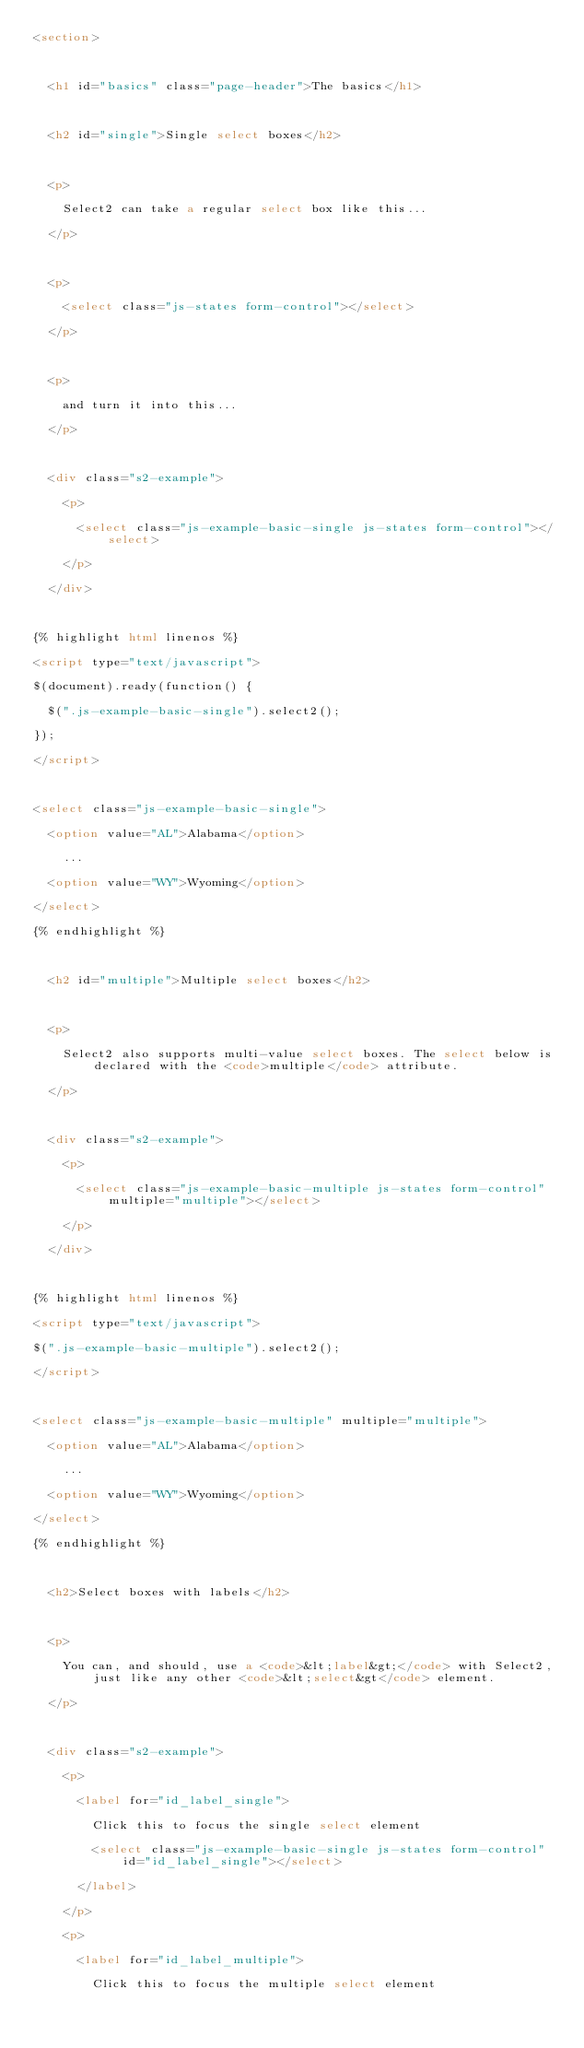<code> <loc_0><loc_0><loc_500><loc_500><_HTML_><section>

  <h1 id="basics" class="page-header">The basics</h1>

  <h2 id="single">Single select boxes</h2>

  <p>
    Select2 can take a regular select box like this...
  </p>

  <p>
    <select class="js-states form-control"></select>
  </p>

  <p>
    and turn it into this...
  </p>

  <div class="s2-example">
    <p>
      <select class="js-example-basic-single js-states form-control"></select>
    </p>
  </div>

{% highlight html linenos %}
<script type="text/javascript">
$(document).ready(function() {
  $(".js-example-basic-single").select2();
});
</script>

<select class="js-example-basic-single">
  <option value="AL">Alabama</option>
    ...
  <option value="WY">Wyoming</option>
</select>
{% endhighlight %}

  <h2 id="multiple">Multiple select boxes</h2>

  <p>
    Select2 also supports multi-value select boxes. The select below is declared with the <code>multiple</code> attribute.
  </p>

  <div class="s2-example">
    <p>
      <select class="js-example-basic-multiple js-states form-control" multiple="multiple"></select>
    </p>
  </div>

{% highlight html linenos %}
<script type="text/javascript">
$(".js-example-basic-multiple").select2();
</script>

<select class="js-example-basic-multiple" multiple="multiple">
  <option value="AL">Alabama</option>
    ...
  <option value="WY">Wyoming</option>
</select>
{% endhighlight %}

  <h2>Select boxes with labels</h2>

  <p>
    You can, and should, use a <code>&lt;label&gt;</code> with Select2, just like any other <code>&lt;select&gt</code> element.
  </p>

  <div class="s2-example">
    <p>
      <label for="id_label_single">
        Click this to focus the single select element
        <select class="js-example-basic-single js-states form-control" id="id_label_single"></select>
      </label>
    </p>
    <p>
      <label for="id_label_multiple">
        Click this to focus the multiple select element</code> 